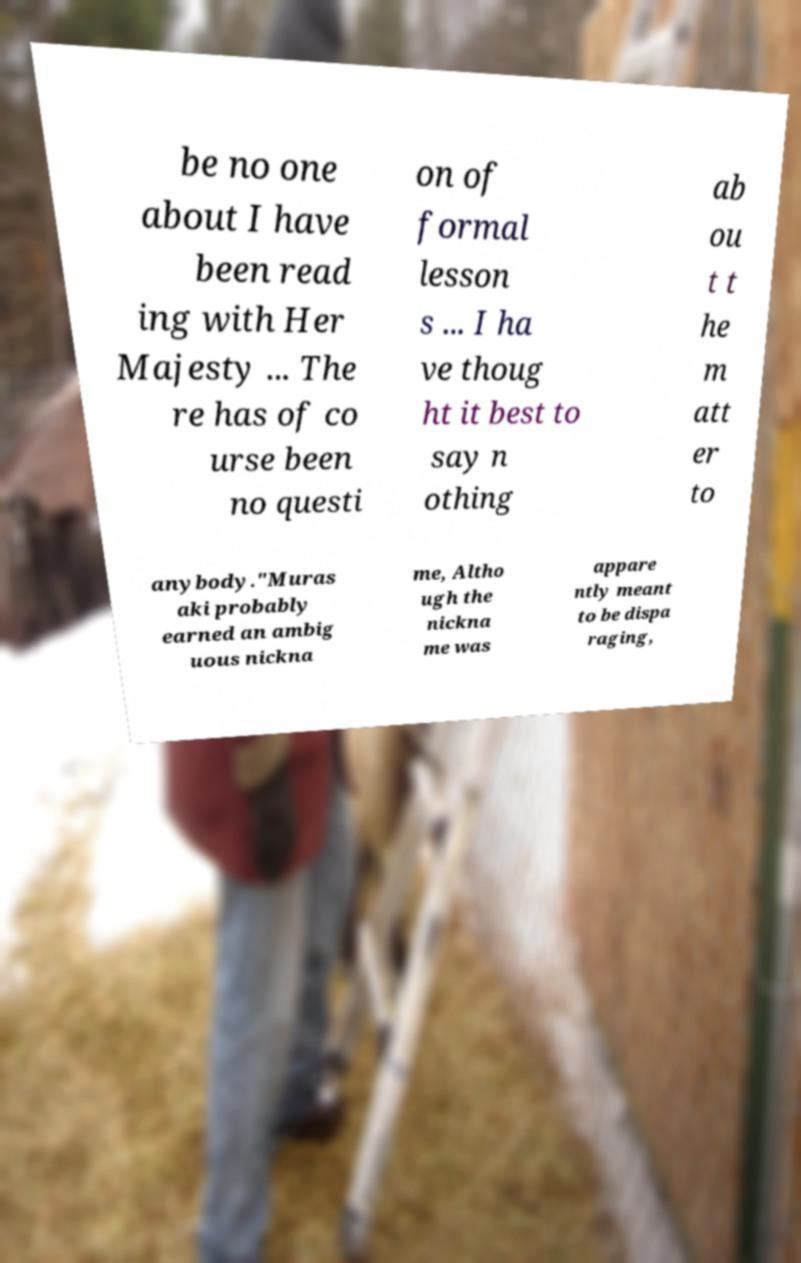For documentation purposes, I need the text within this image transcribed. Could you provide that? be no one about I have been read ing with Her Majesty ... The re has of co urse been no questi on of formal lesson s ... I ha ve thoug ht it best to say n othing ab ou t t he m att er to anybody."Muras aki probably earned an ambig uous nickna me, Altho ugh the nickna me was appare ntly meant to be dispa raging, 